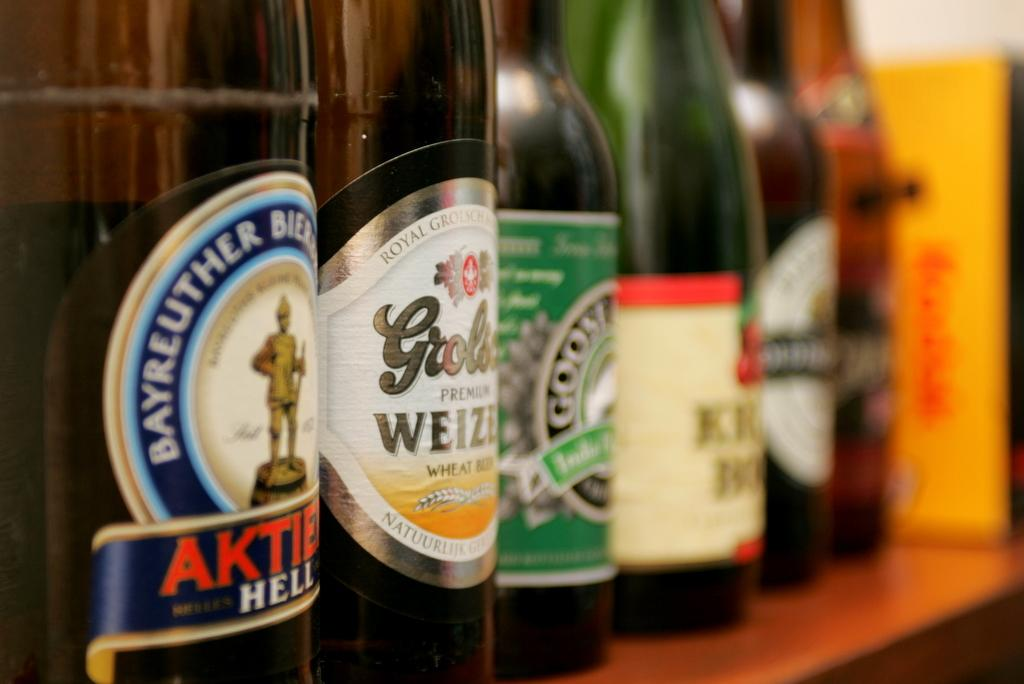<image>
Summarize the visual content of the image. the word Bayreuther that is on a wine bottle 